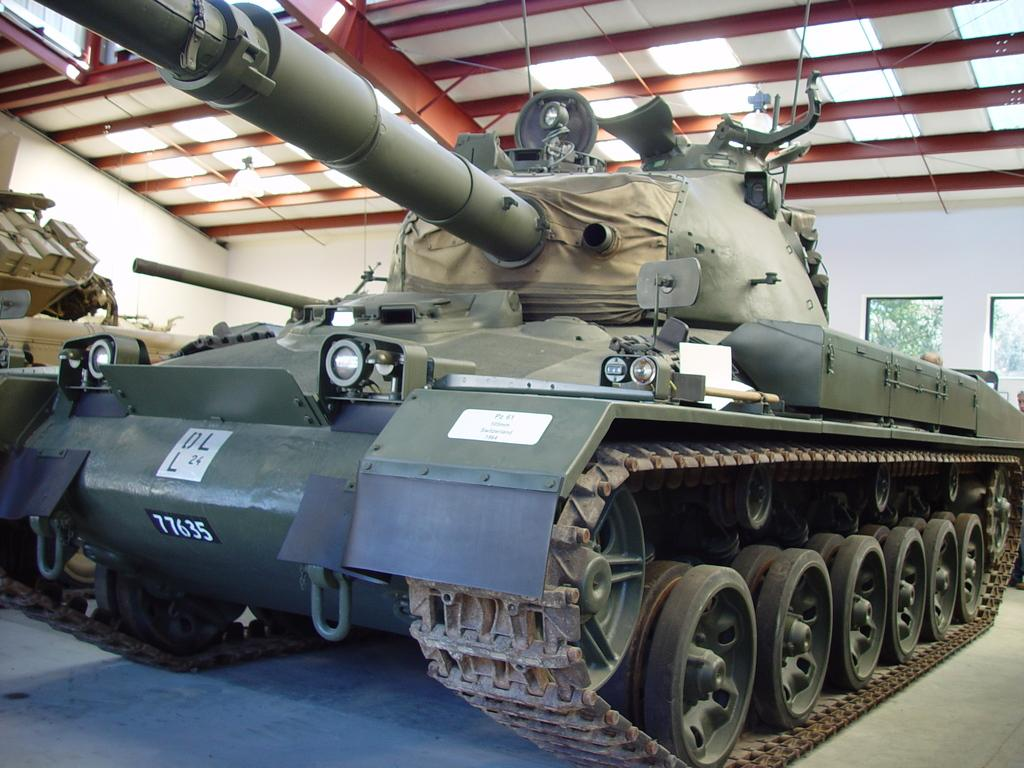What is the main subject in the center of the image? There is a battle tank in the center of the image. What can be seen in the background of the image? There is a wall and glass windows in the background of the image. What is visible through the glass windows? Trees are visible through the glass windows. Are there any other objects in the background of the image? Yes, there are a few other objects in the background of the image. How many fish can be seen swimming in the image? There are no fish present in the image. What letter is written on the battle tank in the image? There is no letter written on the battle tank in the image. 